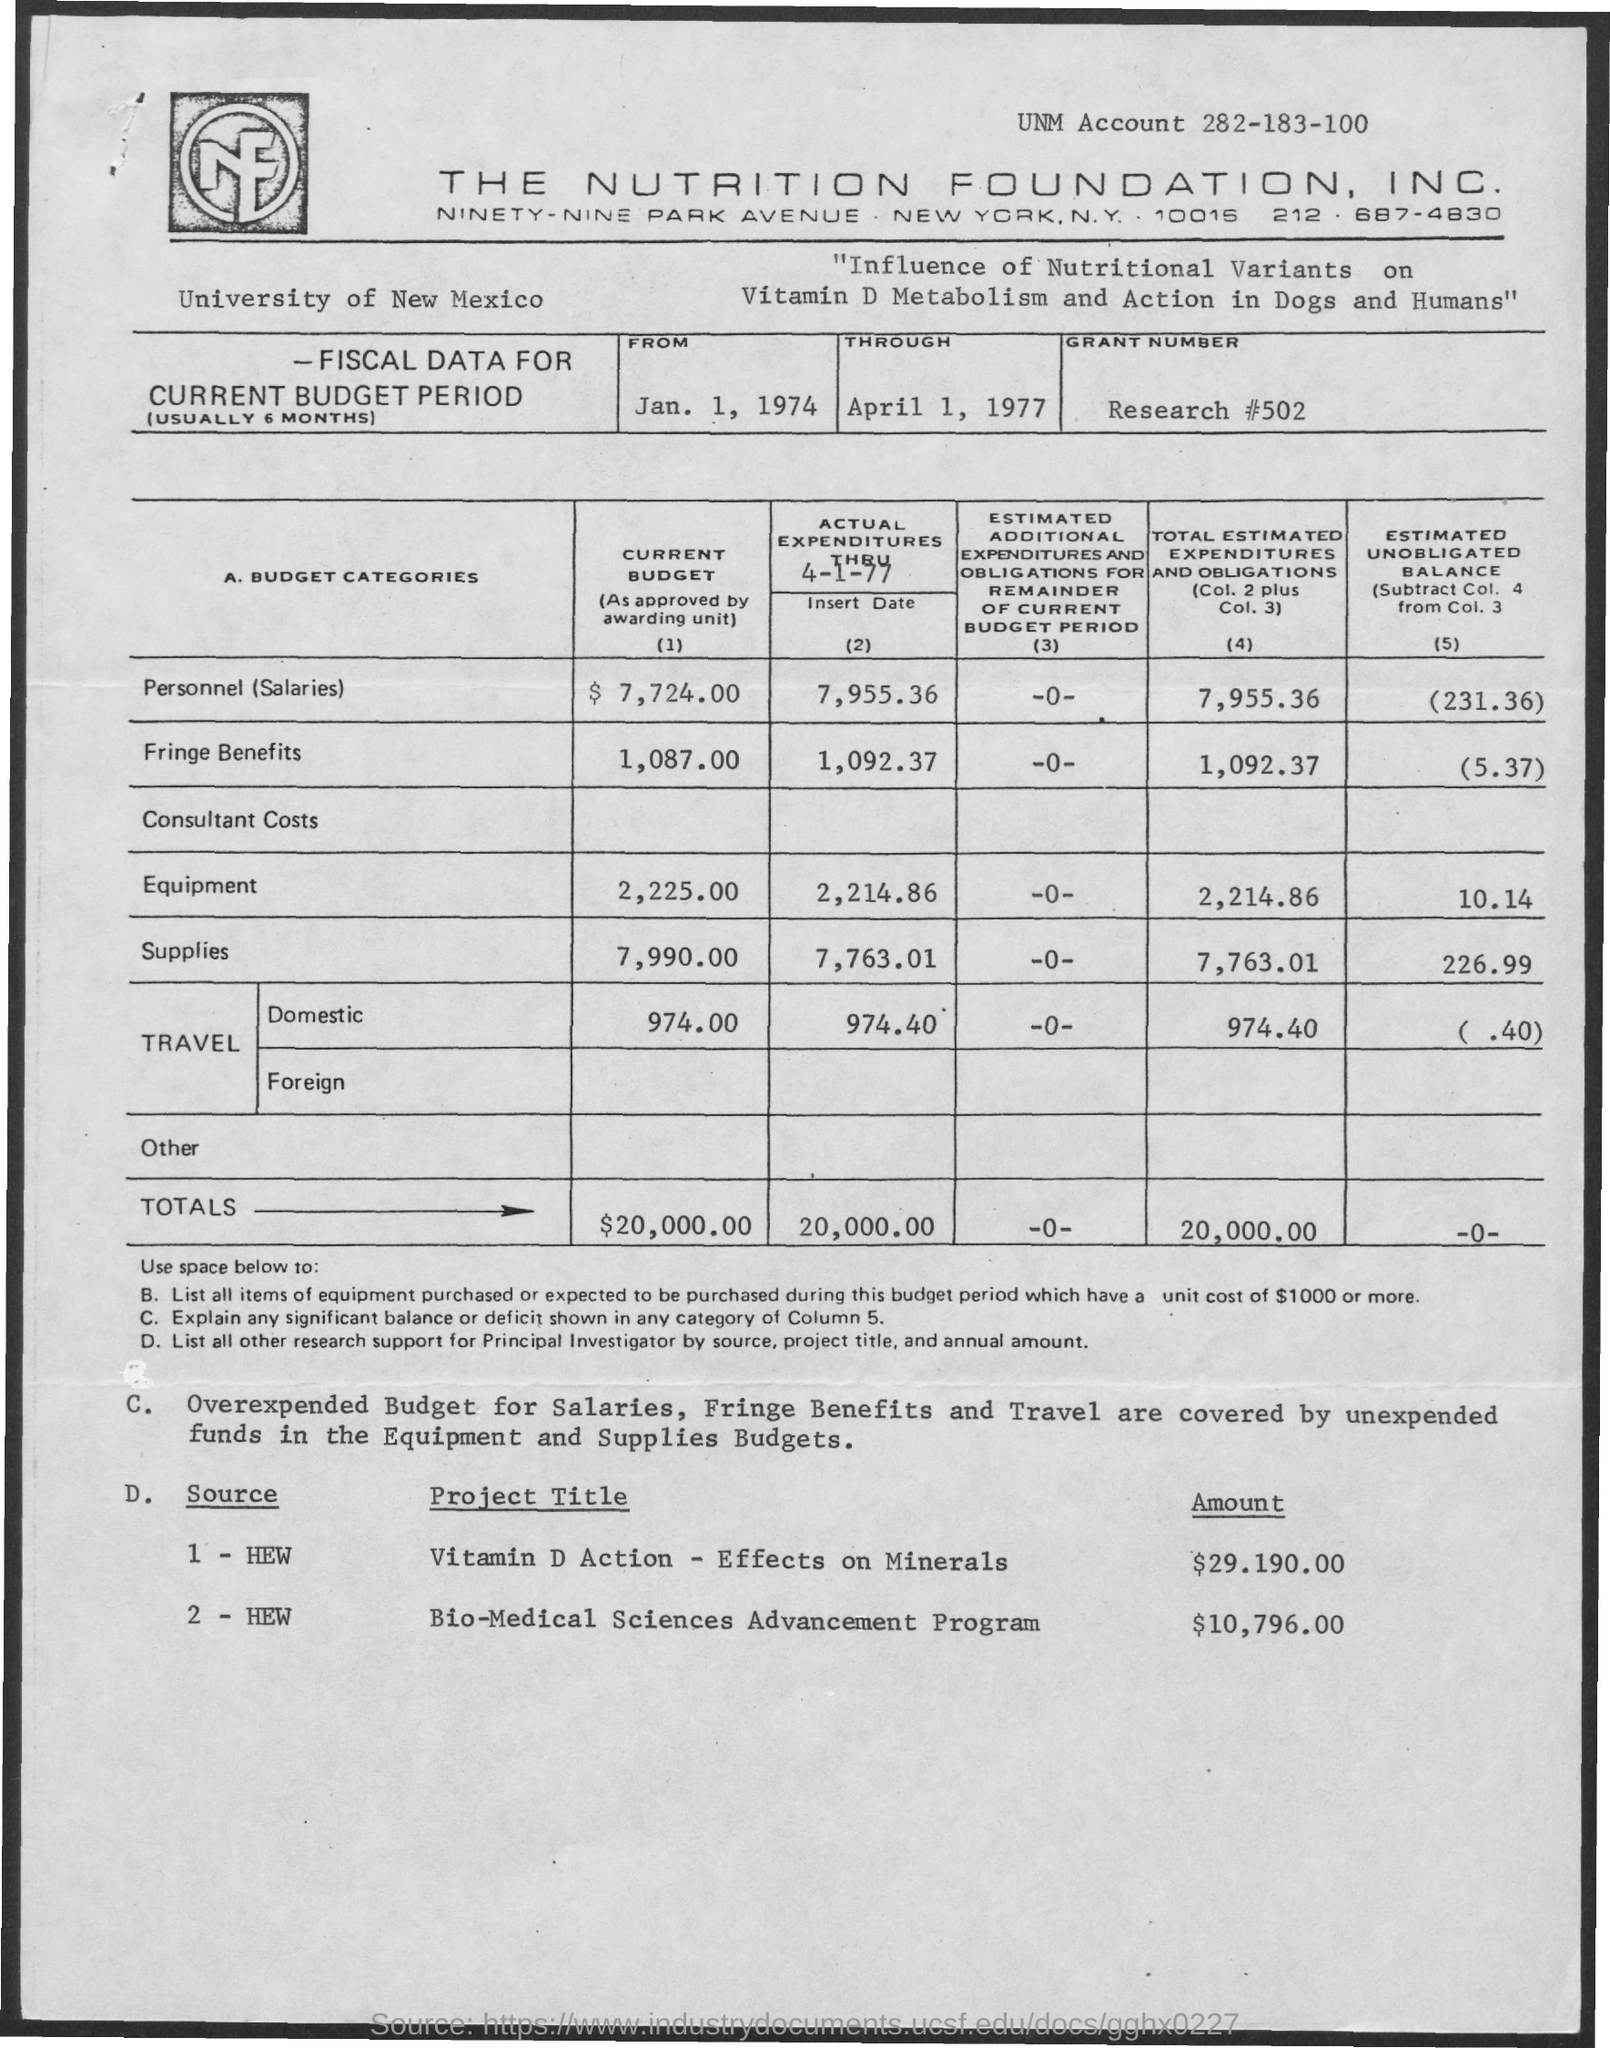Outline some significant characteristics in this image. The budget for the project titled 'Vitamin D Action Effects on Mineral' is $29.190.00. A grant number is a unique identifier assigned to a research project. The specific grant number mentioned is RESEARCH #502. 